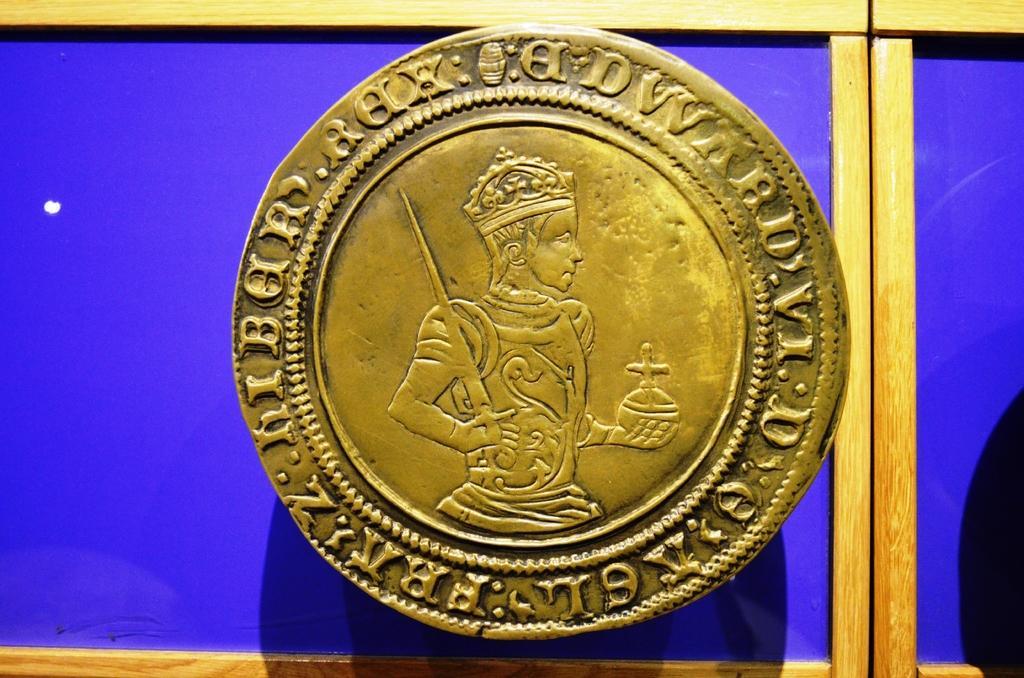How would you summarize this image in a sentence or two? In this picture I can see a coin with some letters and a structure of a person on the coin, and in the background there is a board. 